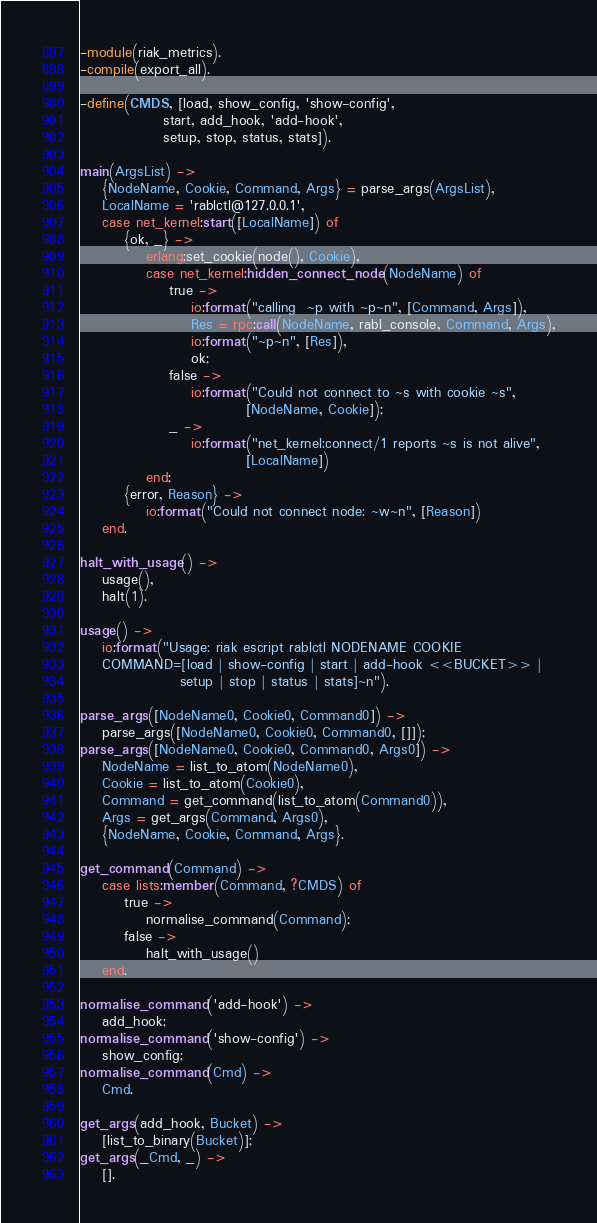<code> <loc_0><loc_0><loc_500><loc_500><_Erlang_>-module(riak_metrics).
-compile(export_all).

-define(CMDS, [load, show_config, 'show-config',
               start, add_hook, 'add-hook',
               setup, stop, status, stats]).

main(ArgsList) ->
    {NodeName, Cookie, Command, Args} = parse_args(ArgsList),
    LocalName = 'rablctl@127.0.0.1',
    case net_kernel:start([LocalName]) of
        {ok, _} ->
            erlang:set_cookie(node(), Cookie),
            case net_kernel:hidden_connect_node(NodeName) of
                true ->
                    io:format("calling  ~p with ~p~n", [Command, Args]),
                    Res = rpc:call(NodeName, rabl_console, Command, Args),
                    io:format("~p~n", [Res]),
                    ok;
                false ->
                    io:format("Could not connect to ~s with cookie ~s",
                              [NodeName, Cookie]);
                _ ->
                    io:format("net_kernel:connect/1 reports ~s is not alive",
                              [LocalName])
            end;
        {error, Reason} ->
            io:format("Could not connect node: ~w~n", [Reason])
    end.

halt_with_usage() ->
    usage(),
    halt(1).

usage() ->
    io:format("Usage: riak escript rablctl NODENAME COOKIE
    COMMAND=[load | show-config | start | add-hook <<BUCKET>> |
                  setup | stop | status | stats]~n").

parse_args([NodeName0, Cookie0, Command0]) ->
    parse_args([NodeName0, Cookie0, Command0, []]);
parse_args([NodeName0, Cookie0, Command0, Args0]) ->
    NodeName = list_to_atom(NodeName0),
    Cookie = list_to_atom(Cookie0),
    Command = get_command(list_to_atom(Command0)),
    Args = get_args(Command, Args0),
    {NodeName, Cookie, Command, Args}.

get_command(Command) ->
    case lists:member(Command, ?CMDS) of
        true ->
            normalise_command(Command);
        false ->
            halt_with_usage()
    end.

normalise_command('add-hook') ->
    add_hook;
normalise_command('show-config') ->
    show_config;
normalise_command(Cmd) ->
    Cmd.

get_args(add_hook, Bucket) ->
    [list_to_binary(Bucket)];
get_args(_Cmd, _) ->
    [].

</code> 